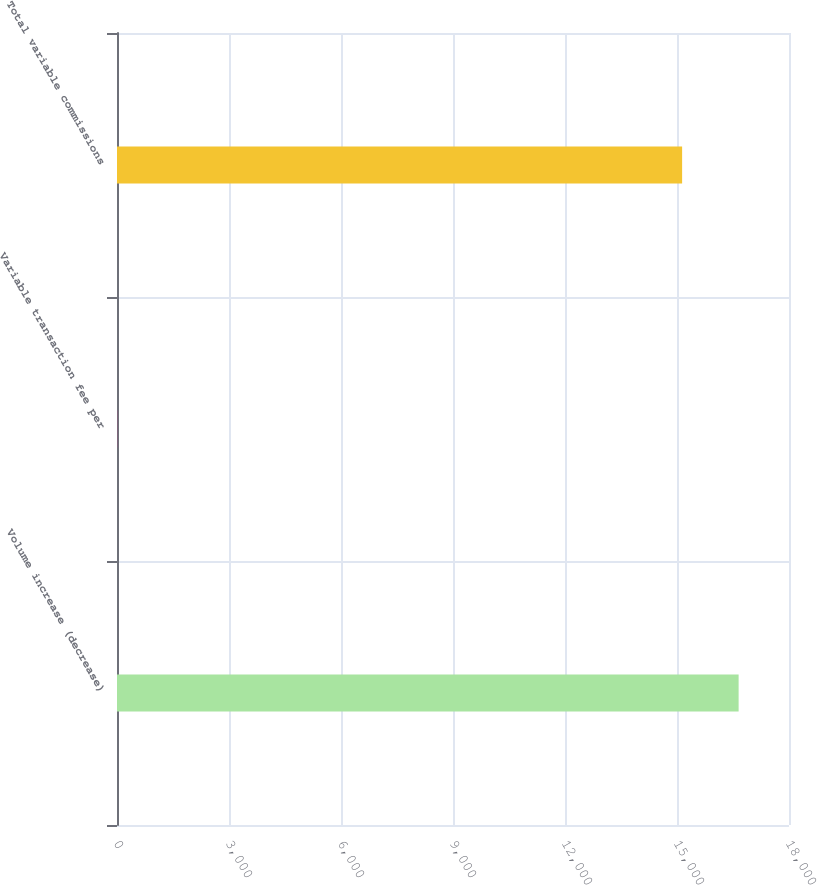Convert chart. <chart><loc_0><loc_0><loc_500><loc_500><bar_chart><fcel>Volume increase (decrease)<fcel>Variable transaction fee per<fcel>Total variable commissions<nl><fcel>16650.7<fcel>3<fcel>15137<nl></chart> 